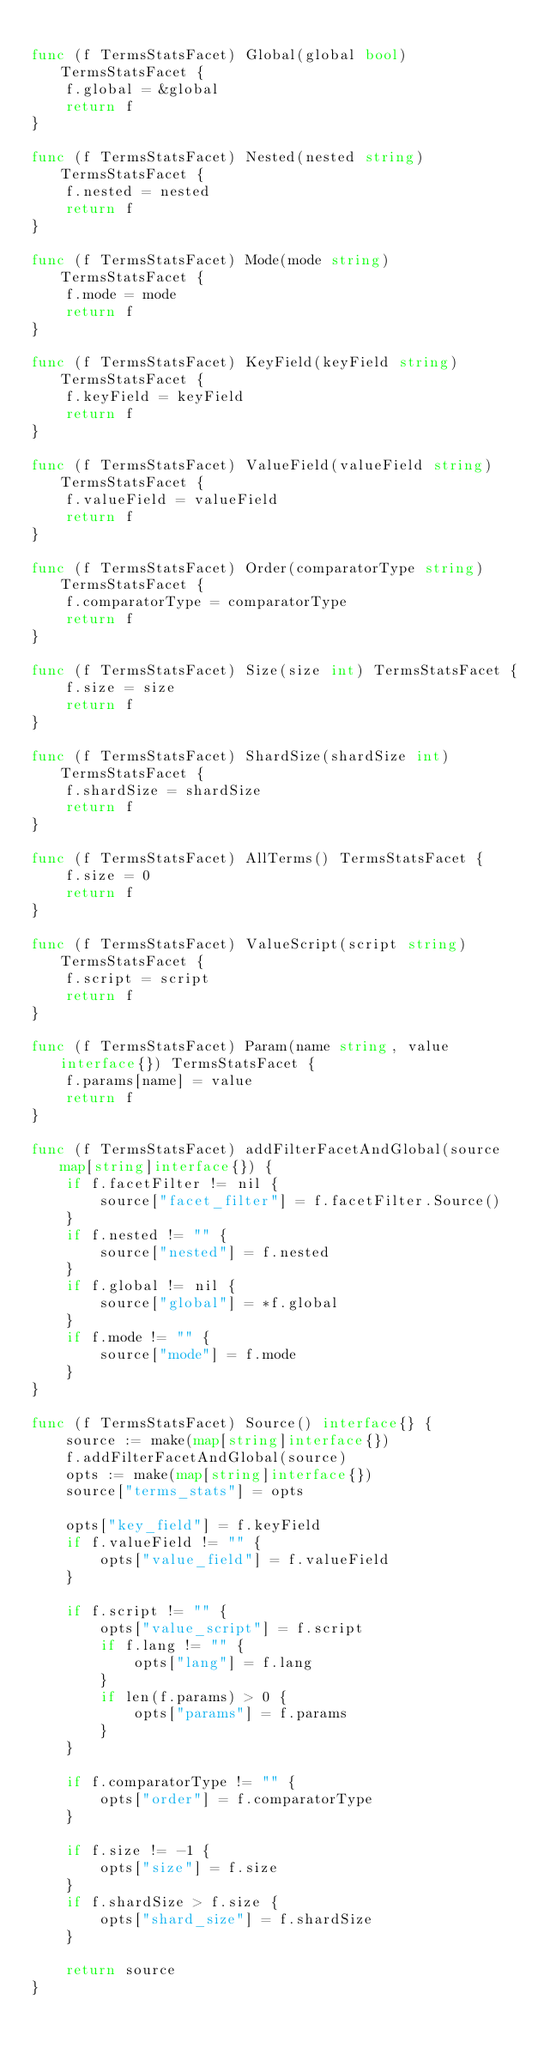<code> <loc_0><loc_0><loc_500><loc_500><_Go_>
func (f TermsStatsFacet) Global(global bool) TermsStatsFacet {
	f.global = &global
	return f
}

func (f TermsStatsFacet) Nested(nested string) TermsStatsFacet {
	f.nested = nested
	return f
}

func (f TermsStatsFacet) Mode(mode string) TermsStatsFacet {
	f.mode = mode
	return f
}

func (f TermsStatsFacet) KeyField(keyField string) TermsStatsFacet {
	f.keyField = keyField
	return f
}

func (f TermsStatsFacet) ValueField(valueField string) TermsStatsFacet {
	f.valueField = valueField
	return f
}

func (f TermsStatsFacet) Order(comparatorType string) TermsStatsFacet {
	f.comparatorType = comparatorType
	return f
}

func (f TermsStatsFacet) Size(size int) TermsStatsFacet {
	f.size = size
	return f
}

func (f TermsStatsFacet) ShardSize(shardSize int) TermsStatsFacet {
	f.shardSize = shardSize
	return f
}

func (f TermsStatsFacet) AllTerms() TermsStatsFacet {
	f.size = 0
	return f
}

func (f TermsStatsFacet) ValueScript(script string) TermsStatsFacet {
	f.script = script
	return f
}

func (f TermsStatsFacet) Param(name string, value interface{}) TermsStatsFacet {
	f.params[name] = value
	return f
}

func (f TermsStatsFacet) addFilterFacetAndGlobal(source map[string]interface{}) {
	if f.facetFilter != nil {
		source["facet_filter"] = f.facetFilter.Source()
	}
	if f.nested != "" {
		source["nested"] = f.nested
	}
	if f.global != nil {
		source["global"] = *f.global
	}
	if f.mode != "" {
		source["mode"] = f.mode
	}
}

func (f TermsStatsFacet) Source() interface{} {
	source := make(map[string]interface{})
	f.addFilterFacetAndGlobal(source)
	opts := make(map[string]interface{})
	source["terms_stats"] = opts

	opts["key_field"] = f.keyField
	if f.valueField != "" {
		opts["value_field"] = f.valueField
	}

	if f.script != "" {
		opts["value_script"] = f.script
		if f.lang != "" {
			opts["lang"] = f.lang
		}
		if len(f.params) > 0 {
			opts["params"] = f.params
		}
	}

	if f.comparatorType != "" {
		opts["order"] = f.comparatorType
	}

	if f.size != -1 {
		opts["size"] = f.size
	}
	if f.shardSize > f.size {
		opts["shard_size"] = f.shardSize
	}

	return source
}
</code> 